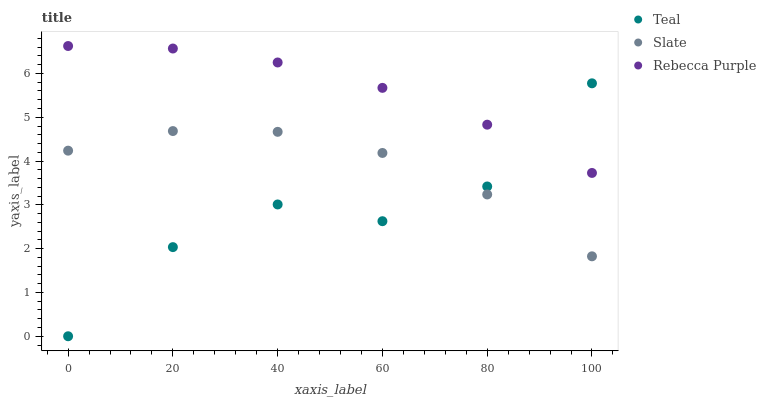Does Teal have the minimum area under the curve?
Answer yes or no. Yes. Does Rebecca Purple have the maximum area under the curve?
Answer yes or no. Yes. Does Rebecca Purple have the minimum area under the curve?
Answer yes or no. No. Does Teal have the maximum area under the curve?
Answer yes or no. No. Is Rebecca Purple the smoothest?
Answer yes or no. Yes. Is Teal the roughest?
Answer yes or no. Yes. Is Teal the smoothest?
Answer yes or no. No. Is Rebecca Purple the roughest?
Answer yes or no. No. Does Teal have the lowest value?
Answer yes or no. Yes. Does Rebecca Purple have the lowest value?
Answer yes or no. No. Does Rebecca Purple have the highest value?
Answer yes or no. Yes. Does Teal have the highest value?
Answer yes or no. No. Is Slate less than Rebecca Purple?
Answer yes or no. Yes. Is Rebecca Purple greater than Slate?
Answer yes or no. Yes. Does Slate intersect Teal?
Answer yes or no. Yes. Is Slate less than Teal?
Answer yes or no. No. Is Slate greater than Teal?
Answer yes or no. No. Does Slate intersect Rebecca Purple?
Answer yes or no. No. 